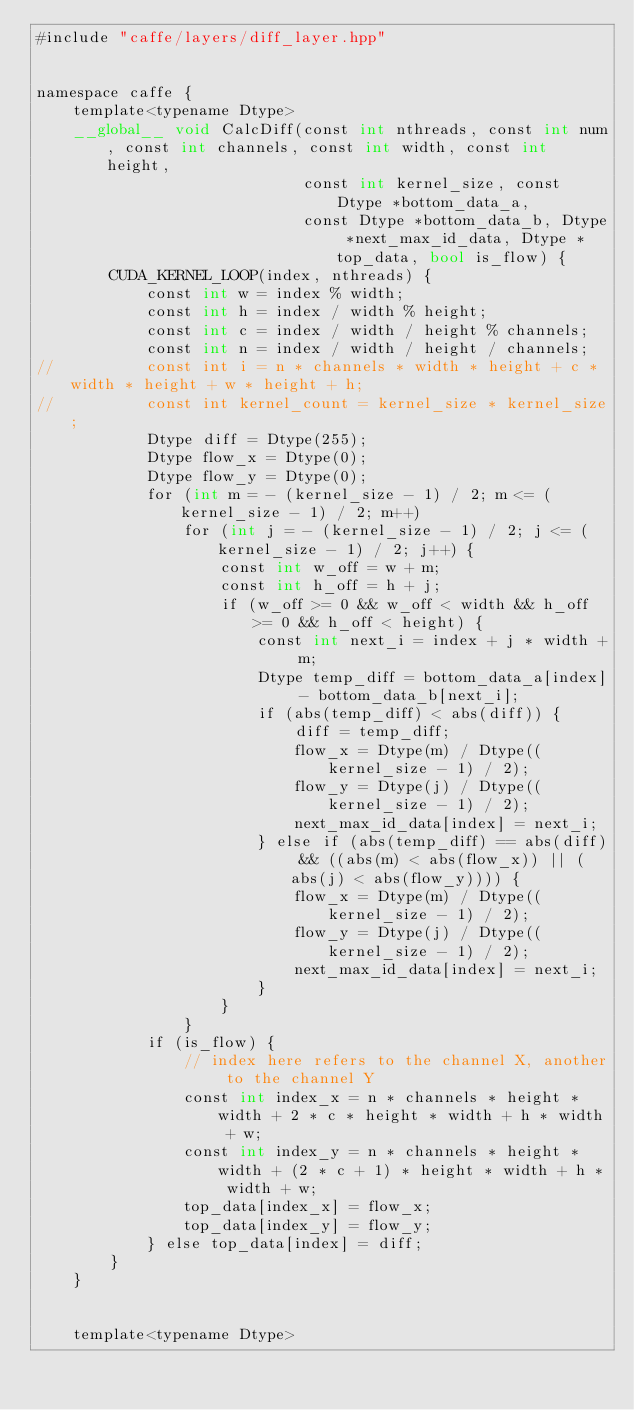<code> <loc_0><loc_0><loc_500><loc_500><_Cuda_>#include "caffe/layers/diff_layer.hpp"


namespace caffe {
	template<typename Dtype>
	__global__ void CalcDiff(const int nthreads, const int num, const int channels, const int width, const int height,
							 const int kernel_size, const Dtype *bottom_data_a,
							 const Dtype *bottom_data_b, Dtype *next_max_id_data, Dtype *top_data, bool is_flow) {
		CUDA_KERNEL_LOOP(index, nthreads) {
			const int w = index % width;
			const int h = index / width % height;
			const int c = index / width / height % channels;
			const int n = index / width / height / channels;
//			const int i = n * channels * width * height + c * width * height + w * height + h;
//			const int kernel_count = kernel_size * kernel_size;
			Dtype diff = Dtype(255);
			Dtype flow_x = Dtype(0);
			Dtype flow_y = Dtype(0);
			for (int m = - (kernel_size - 1) / 2; m <= (kernel_size - 1) / 2; m++)
				for (int j = - (kernel_size - 1) / 2; j <= (kernel_size - 1) / 2; j++) {
					const int w_off = w + m;
					const int h_off = h + j;
					if (w_off >= 0 && w_off < width && h_off >= 0 && h_off < height) {
						const int next_i = index + j * width + m;
						Dtype temp_diff = bottom_data_a[index] - bottom_data_b[next_i];
						if (abs(temp_diff) < abs(diff)) {
							diff = temp_diff;
							flow_x = Dtype(m) / Dtype((kernel_size - 1) / 2);
							flow_y = Dtype(j) / Dtype((kernel_size - 1) / 2);
							next_max_id_data[index] = next_i;
						} else if (abs(temp_diff) == abs(diff) && ((abs(m) < abs(flow_x)) || (abs(j) < abs(flow_y)))) {
							flow_x = Dtype(m) / Dtype((kernel_size - 1) / 2);
							flow_y = Dtype(j) / Dtype((kernel_size - 1) / 2);
							next_max_id_data[index] = next_i;
						}
					}
				}
			if (is_flow) {
				// index here refers to the channel X, another to the channel Y
				const int index_x = n * channels * height * width + 2 * c * height * width + h * width + w;
				const int index_y = n * channels * height * width + (2 * c + 1) * height * width + h * width + w;
				top_data[index_x] = flow_x;
				top_data[index_y] = flow_y;
			} else top_data[index] = diff;
		}
	}


	template<typename Dtype></code> 